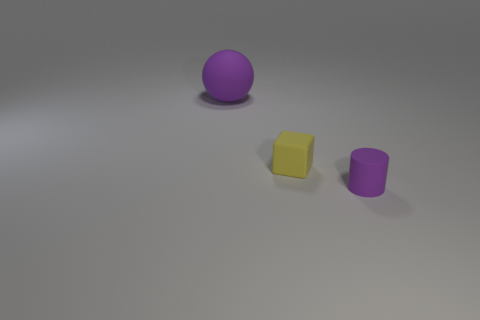Add 1 large purple matte objects. How many objects exist? 4 Subtract all cylinders. How many objects are left? 2 Subtract all matte cylinders. Subtract all yellow things. How many objects are left? 1 Add 2 yellow objects. How many yellow objects are left? 3 Add 2 rubber balls. How many rubber balls exist? 3 Subtract 1 purple cylinders. How many objects are left? 2 